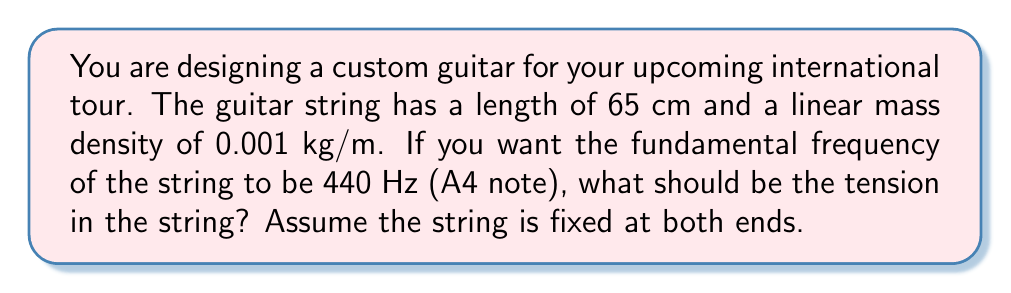Provide a solution to this math problem. To solve this problem, we'll use the equation for the fundamental frequency of a vibrating string:

$$ f = \frac{1}{2L}\sqrt{\frac{T}{\mu}} $$

Where:
$f$ = fundamental frequency (Hz)
$L$ = length of the string (m)
$T$ = tension in the string (N)
$\mu$ = linear mass density (kg/m)

Given:
$f = 440$ Hz
$L = 65$ cm $= 0.65$ m
$\mu = 0.001$ kg/m

Step 1: Rearrange the equation to solve for T:

$$ T = 4L^2f^2\mu $$

Step 2: Substitute the known values:

$$ T = 4(0.65\text{ m})^2(440\text{ Hz})^2(0.001\text{ kg/m}) $$

Step 3: Calculate the result:

$$ T = 4 \cdot 0.4225 \cdot 193600 \cdot 0.001 $$
$$ T = 327.184 \text{ N} $$

Therefore, the tension in the string should be approximately 327.2 N.
Answer: $327.2\text{ N}$ 